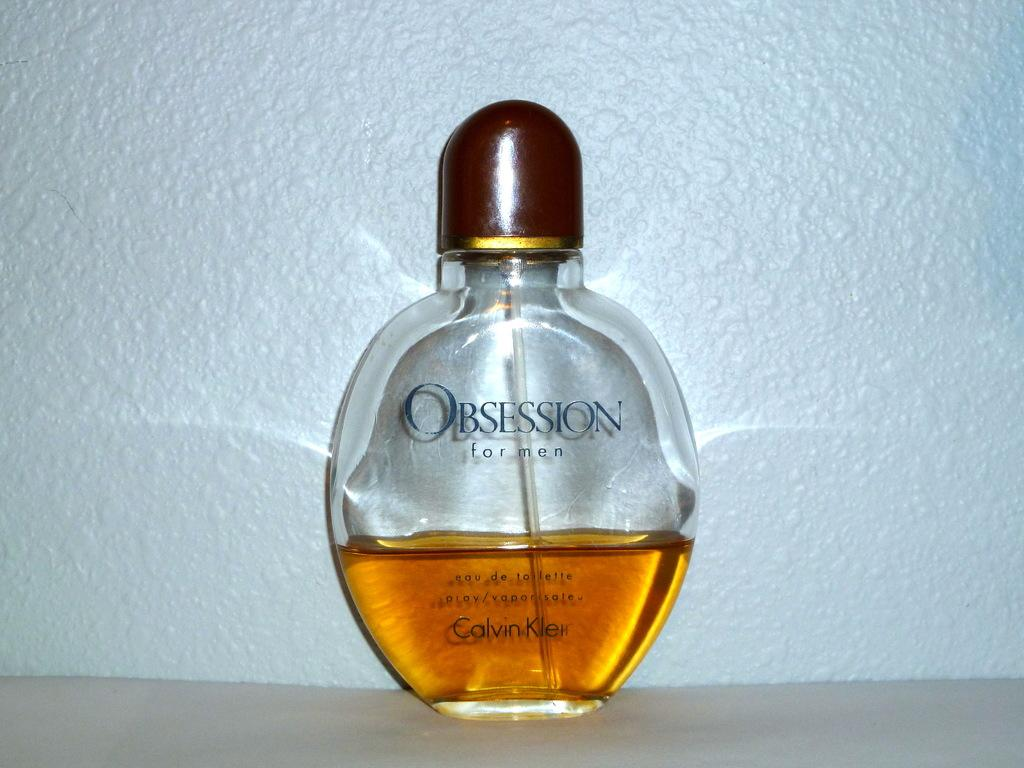<image>
Write a terse but informative summary of the picture. A half empty bottle of Calvin Klein's Obsession perfume. 